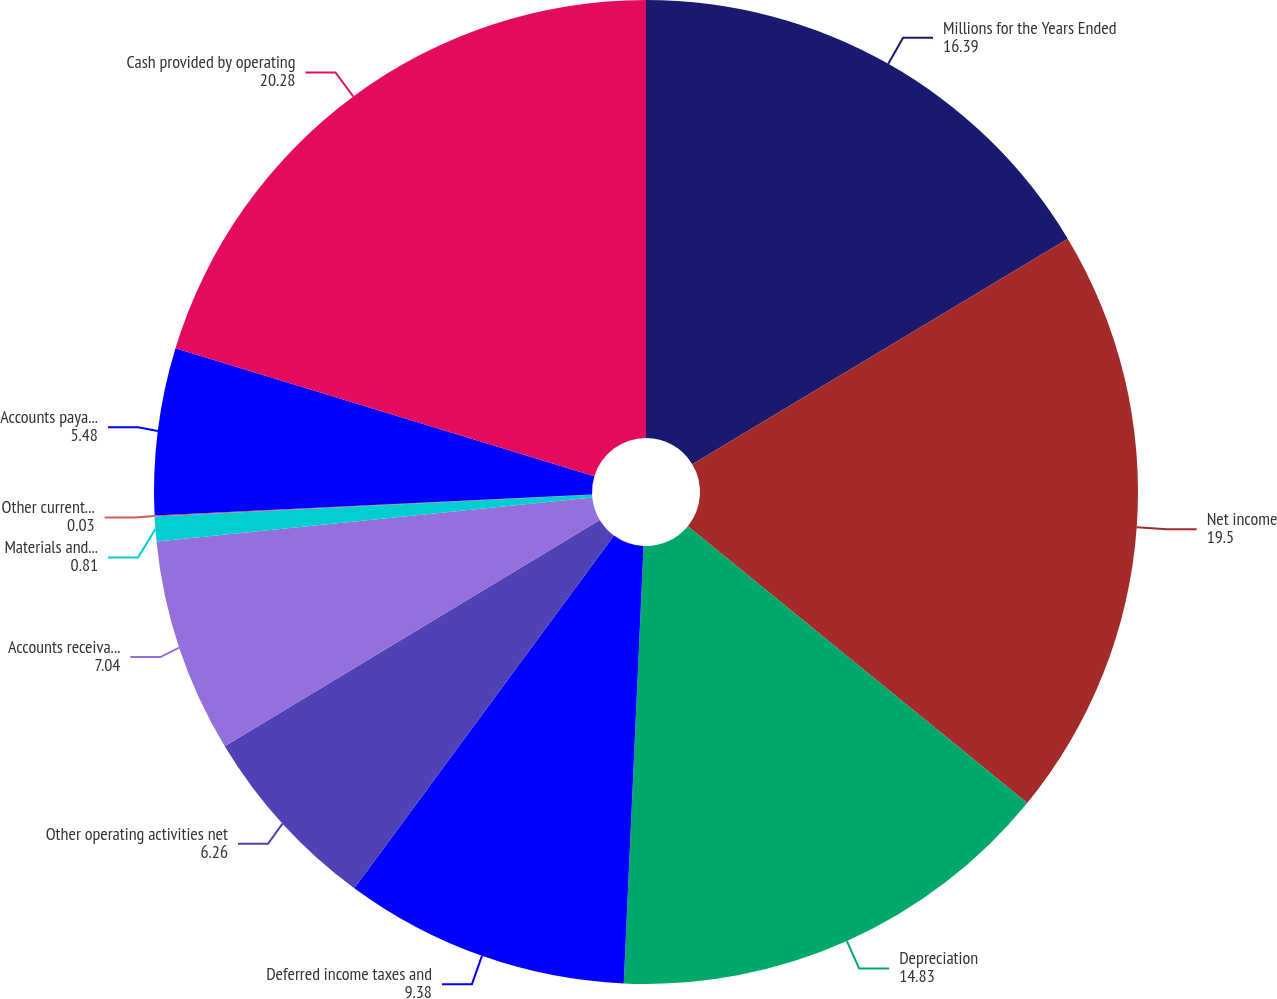<chart> <loc_0><loc_0><loc_500><loc_500><pie_chart><fcel>Millions for the Years Ended<fcel>Net income<fcel>Depreciation<fcel>Deferred income taxes and<fcel>Other operating activities net<fcel>Accounts receivable net<fcel>Materials and supplies<fcel>Other current assets<fcel>Accounts payable and other<fcel>Cash provided by operating<nl><fcel>16.39%<fcel>19.5%<fcel>14.83%<fcel>9.38%<fcel>6.26%<fcel>7.04%<fcel>0.81%<fcel>0.03%<fcel>5.48%<fcel>20.28%<nl></chart> 